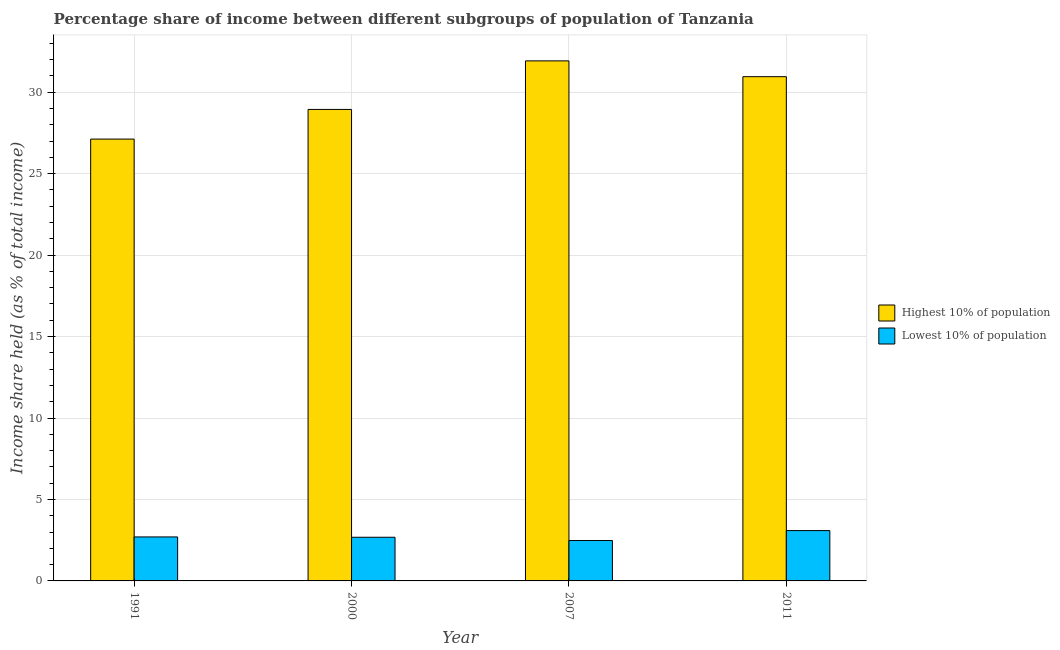How many different coloured bars are there?
Make the answer very short. 2. How many groups of bars are there?
Keep it short and to the point. 4. How many bars are there on the 3rd tick from the right?
Keep it short and to the point. 2. What is the label of the 1st group of bars from the left?
Offer a very short reply. 1991. What is the income share held by lowest 10% of the population in 2011?
Provide a short and direct response. 3.09. Across all years, what is the maximum income share held by lowest 10% of the population?
Your response must be concise. 3.09. Across all years, what is the minimum income share held by lowest 10% of the population?
Give a very brief answer. 2.48. In which year was the income share held by lowest 10% of the population minimum?
Your answer should be compact. 2007. What is the total income share held by highest 10% of the population in the graph?
Offer a terse response. 118.93. What is the difference between the income share held by highest 10% of the population in 2000 and that in 2011?
Your answer should be very brief. -2.01. What is the difference between the income share held by lowest 10% of the population in 2011 and the income share held by highest 10% of the population in 2007?
Make the answer very short. 0.61. What is the average income share held by highest 10% of the population per year?
Keep it short and to the point. 29.73. In how many years, is the income share held by lowest 10% of the population greater than 21 %?
Keep it short and to the point. 0. What is the ratio of the income share held by lowest 10% of the population in 2000 to that in 2007?
Ensure brevity in your answer.  1.08. Is the difference between the income share held by highest 10% of the population in 1991 and 2011 greater than the difference between the income share held by lowest 10% of the population in 1991 and 2011?
Offer a terse response. No. What is the difference between the highest and the second highest income share held by lowest 10% of the population?
Offer a terse response. 0.39. What is the difference between the highest and the lowest income share held by lowest 10% of the population?
Give a very brief answer. 0.61. In how many years, is the income share held by lowest 10% of the population greater than the average income share held by lowest 10% of the population taken over all years?
Offer a very short reply. 1. Is the sum of the income share held by highest 10% of the population in 1991 and 2011 greater than the maximum income share held by lowest 10% of the population across all years?
Your answer should be very brief. Yes. What does the 1st bar from the left in 2011 represents?
Provide a succinct answer. Highest 10% of population. What does the 2nd bar from the right in 1991 represents?
Offer a very short reply. Highest 10% of population. What is the difference between two consecutive major ticks on the Y-axis?
Give a very brief answer. 5. Where does the legend appear in the graph?
Provide a succinct answer. Center right. How many legend labels are there?
Make the answer very short. 2. How are the legend labels stacked?
Offer a very short reply. Vertical. What is the title of the graph?
Offer a very short reply. Percentage share of income between different subgroups of population of Tanzania. Does "Secondary Education" appear as one of the legend labels in the graph?
Provide a succinct answer. No. What is the label or title of the Y-axis?
Provide a succinct answer. Income share held (as % of total income). What is the Income share held (as % of total income) of Highest 10% of population in 1991?
Offer a very short reply. 27.12. What is the Income share held (as % of total income) of Highest 10% of population in 2000?
Keep it short and to the point. 28.94. What is the Income share held (as % of total income) of Lowest 10% of population in 2000?
Provide a succinct answer. 2.68. What is the Income share held (as % of total income) in Highest 10% of population in 2007?
Give a very brief answer. 31.92. What is the Income share held (as % of total income) in Lowest 10% of population in 2007?
Your answer should be very brief. 2.48. What is the Income share held (as % of total income) in Highest 10% of population in 2011?
Your answer should be compact. 30.95. What is the Income share held (as % of total income) of Lowest 10% of population in 2011?
Ensure brevity in your answer.  3.09. Across all years, what is the maximum Income share held (as % of total income) in Highest 10% of population?
Offer a terse response. 31.92. Across all years, what is the maximum Income share held (as % of total income) in Lowest 10% of population?
Give a very brief answer. 3.09. Across all years, what is the minimum Income share held (as % of total income) of Highest 10% of population?
Provide a short and direct response. 27.12. Across all years, what is the minimum Income share held (as % of total income) in Lowest 10% of population?
Your response must be concise. 2.48. What is the total Income share held (as % of total income) of Highest 10% of population in the graph?
Provide a succinct answer. 118.93. What is the total Income share held (as % of total income) in Lowest 10% of population in the graph?
Provide a short and direct response. 10.95. What is the difference between the Income share held (as % of total income) in Highest 10% of population in 1991 and that in 2000?
Your answer should be very brief. -1.82. What is the difference between the Income share held (as % of total income) in Lowest 10% of population in 1991 and that in 2007?
Provide a short and direct response. 0.22. What is the difference between the Income share held (as % of total income) in Highest 10% of population in 1991 and that in 2011?
Your response must be concise. -3.83. What is the difference between the Income share held (as % of total income) of Lowest 10% of population in 1991 and that in 2011?
Provide a short and direct response. -0.39. What is the difference between the Income share held (as % of total income) in Highest 10% of population in 2000 and that in 2007?
Your answer should be very brief. -2.98. What is the difference between the Income share held (as % of total income) of Lowest 10% of population in 2000 and that in 2007?
Give a very brief answer. 0.2. What is the difference between the Income share held (as % of total income) in Highest 10% of population in 2000 and that in 2011?
Give a very brief answer. -2.01. What is the difference between the Income share held (as % of total income) in Lowest 10% of population in 2000 and that in 2011?
Offer a very short reply. -0.41. What is the difference between the Income share held (as % of total income) in Lowest 10% of population in 2007 and that in 2011?
Your response must be concise. -0.61. What is the difference between the Income share held (as % of total income) of Highest 10% of population in 1991 and the Income share held (as % of total income) of Lowest 10% of population in 2000?
Offer a terse response. 24.44. What is the difference between the Income share held (as % of total income) of Highest 10% of population in 1991 and the Income share held (as % of total income) of Lowest 10% of population in 2007?
Make the answer very short. 24.64. What is the difference between the Income share held (as % of total income) in Highest 10% of population in 1991 and the Income share held (as % of total income) in Lowest 10% of population in 2011?
Offer a terse response. 24.03. What is the difference between the Income share held (as % of total income) in Highest 10% of population in 2000 and the Income share held (as % of total income) in Lowest 10% of population in 2007?
Provide a succinct answer. 26.46. What is the difference between the Income share held (as % of total income) in Highest 10% of population in 2000 and the Income share held (as % of total income) in Lowest 10% of population in 2011?
Give a very brief answer. 25.85. What is the difference between the Income share held (as % of total income) of Highest 10% of population in 2007 and the Income share held (as % of total income) of Lowest 10% of population in 2011?
Your answer should be compact. 28.83. What is the average Income share held (as % of total income) of Highest 10% of population per year?
Your response must be concise. 29.73. What is the average Income share held (as % of total income) in Lowest 10% of population per year?
Your answer should be very brief. 2.74. In the year 1991, what is the difference between the Income share held (as % of total income) of Highest 10% of population and Income share held (as % of total income) of Lowest 10% of population?
Your answer should be compact. 24.42. In the year 2000, what is the difference between the Income share held (as % of total income) in Highest 10% of population and Income share held (as % of total income) in Lowest 10% of population?
Give a very brief answer. 26.26. In the year 2007, what is the difference between the Income share held (as % of total income) in Highest 10% of population and Income share held (as % of total income) in Lowest 10% of population?
Make the answer very short. 29.44. In the year 2011, what is the difference between the Income share held (as % of total income) of Highest 10% of population and Income share held (as % of total income) of Lowest 10% of population?
Make the answer very short. 27.86. What is the ratio of the Income share held (as % of total income) of Highest 10% of population in 1991 to that in 2000?
Keep it short and to the point. 0.94. What is the ratio of the Income share held (as % of total income) of Lowest 10% of population in 1991 to that in 2000?
Keep it short and to the point. 1.01. What is the ratio of the Income share held (as % of total income) of Highest 10% of population in 1991 to that in 2007?
Make the answer very short. 0.85. What is the ratio of the Income share held (as % of total income) in Lowest 10% of population in 1991 to that in 2007?
Provide a short and direct response. 1.09. What is the ratio of the Income share held (as % of total income) in Highest 10% of population in 1991 to that in 2011?
Provide a succinct answer. 0.88. What is the ratio of the Income share held (as % of total income) of Lowest 10% of population in 1991 to that in 2011?
Provide a short and direct response. 0.87. What is the ratio of the Income share held (as % of total income) of Highest 10% of population in 2000 to that in 2007?
Your answer should be very brief. 0.91. What is the ratio of the Income share held (as % of total income) of Lowest 10% of population in 2000 to that in 2007?
Ensure brevity in your answer.  1.08. What is the ratio of the Income share held (as % of total income) in Highest 10% of population in 2000 to that in 2011?
Provide a succinct answer. 0.94. What is the ratio of the Income share held (as % of total income) in Lowest 10% of population in 2000 to that in 2011?
Your response must be concise. 0.87. What is the ratio of the Income share held (as % of total income) of Highest 10% of population in 2007 to that in 2011?
Ensure brevity in your answer.  1.03. What is the ratio of the Income share held (as % of total income) in Lowest 10% of population in 2007 to that in 2011?
Ensure brevity in your answer.  0.8. What is the difference between the highest and the second highest Income share held (as % of total income) in Lowest 10% of population?
Ensure brevity in your answer.  0.39. What is the difference between the highest and the lowest Income share held (as % of total income) of Highest 10% of population?
Keep it short and to the point. 4.8. What is the difference between the highest and the lowest Income share held (as % of total income) in Lowest 10% of population?
Give a very brief answer. 0.61. 